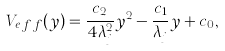Convert formula to latex. <formula><loc_0><loc_0><loc_500><loc_500>V _ { e \, f \, f } ( y ) = \frac { c _ { 2 } } { 4 \lambda _ { j } ^ { 2 } } y ^ { 2 } - \frac { c _ { 1 } } { \lambda _ { j } } y + c _ { 0 } ,</formula> 